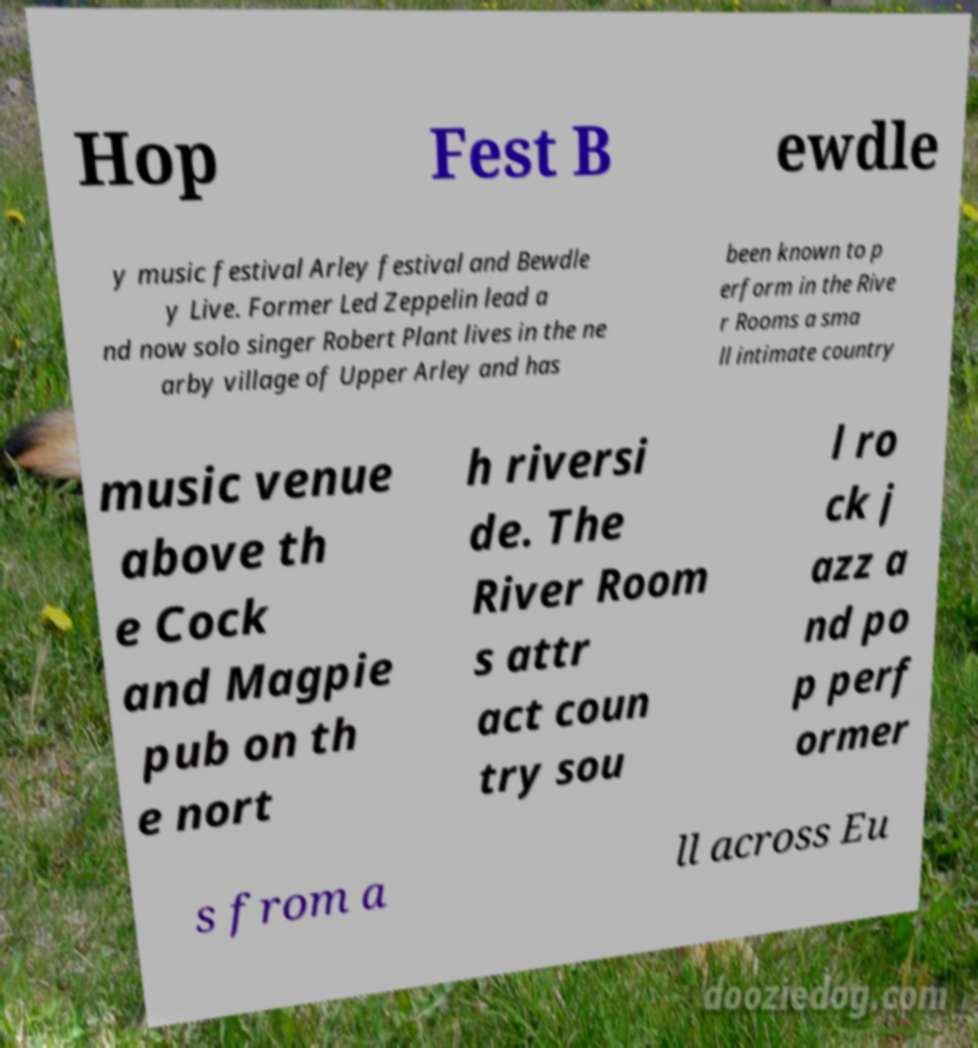Could you extract and type out the text from this image? Hop Fest B ewdle y music festival Arley festival and Bewdle y Live. Former Led Zeppelin lead a nd now solo singer Robert Plant lives in the ne arby village of Upper Arley and has been known to p erform in the Rive r Rooms a sma ll intimate country music venue above th e Cock and Magpie pub on th e nort h riversi de. The River Room s attr act coun try sou l ro ck j azz a nd po p perf ormer s from a ll across Eu 